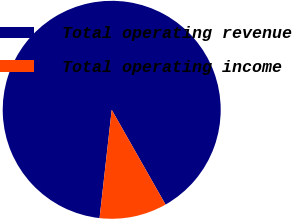<chart> <loc_0><loc_0><loc_500><loc_500><pie_chart><fcel>Total operating revenue<fcel>Total operating income<nl><fcel>90.0%<fcel>10.0%<nl></chart> 